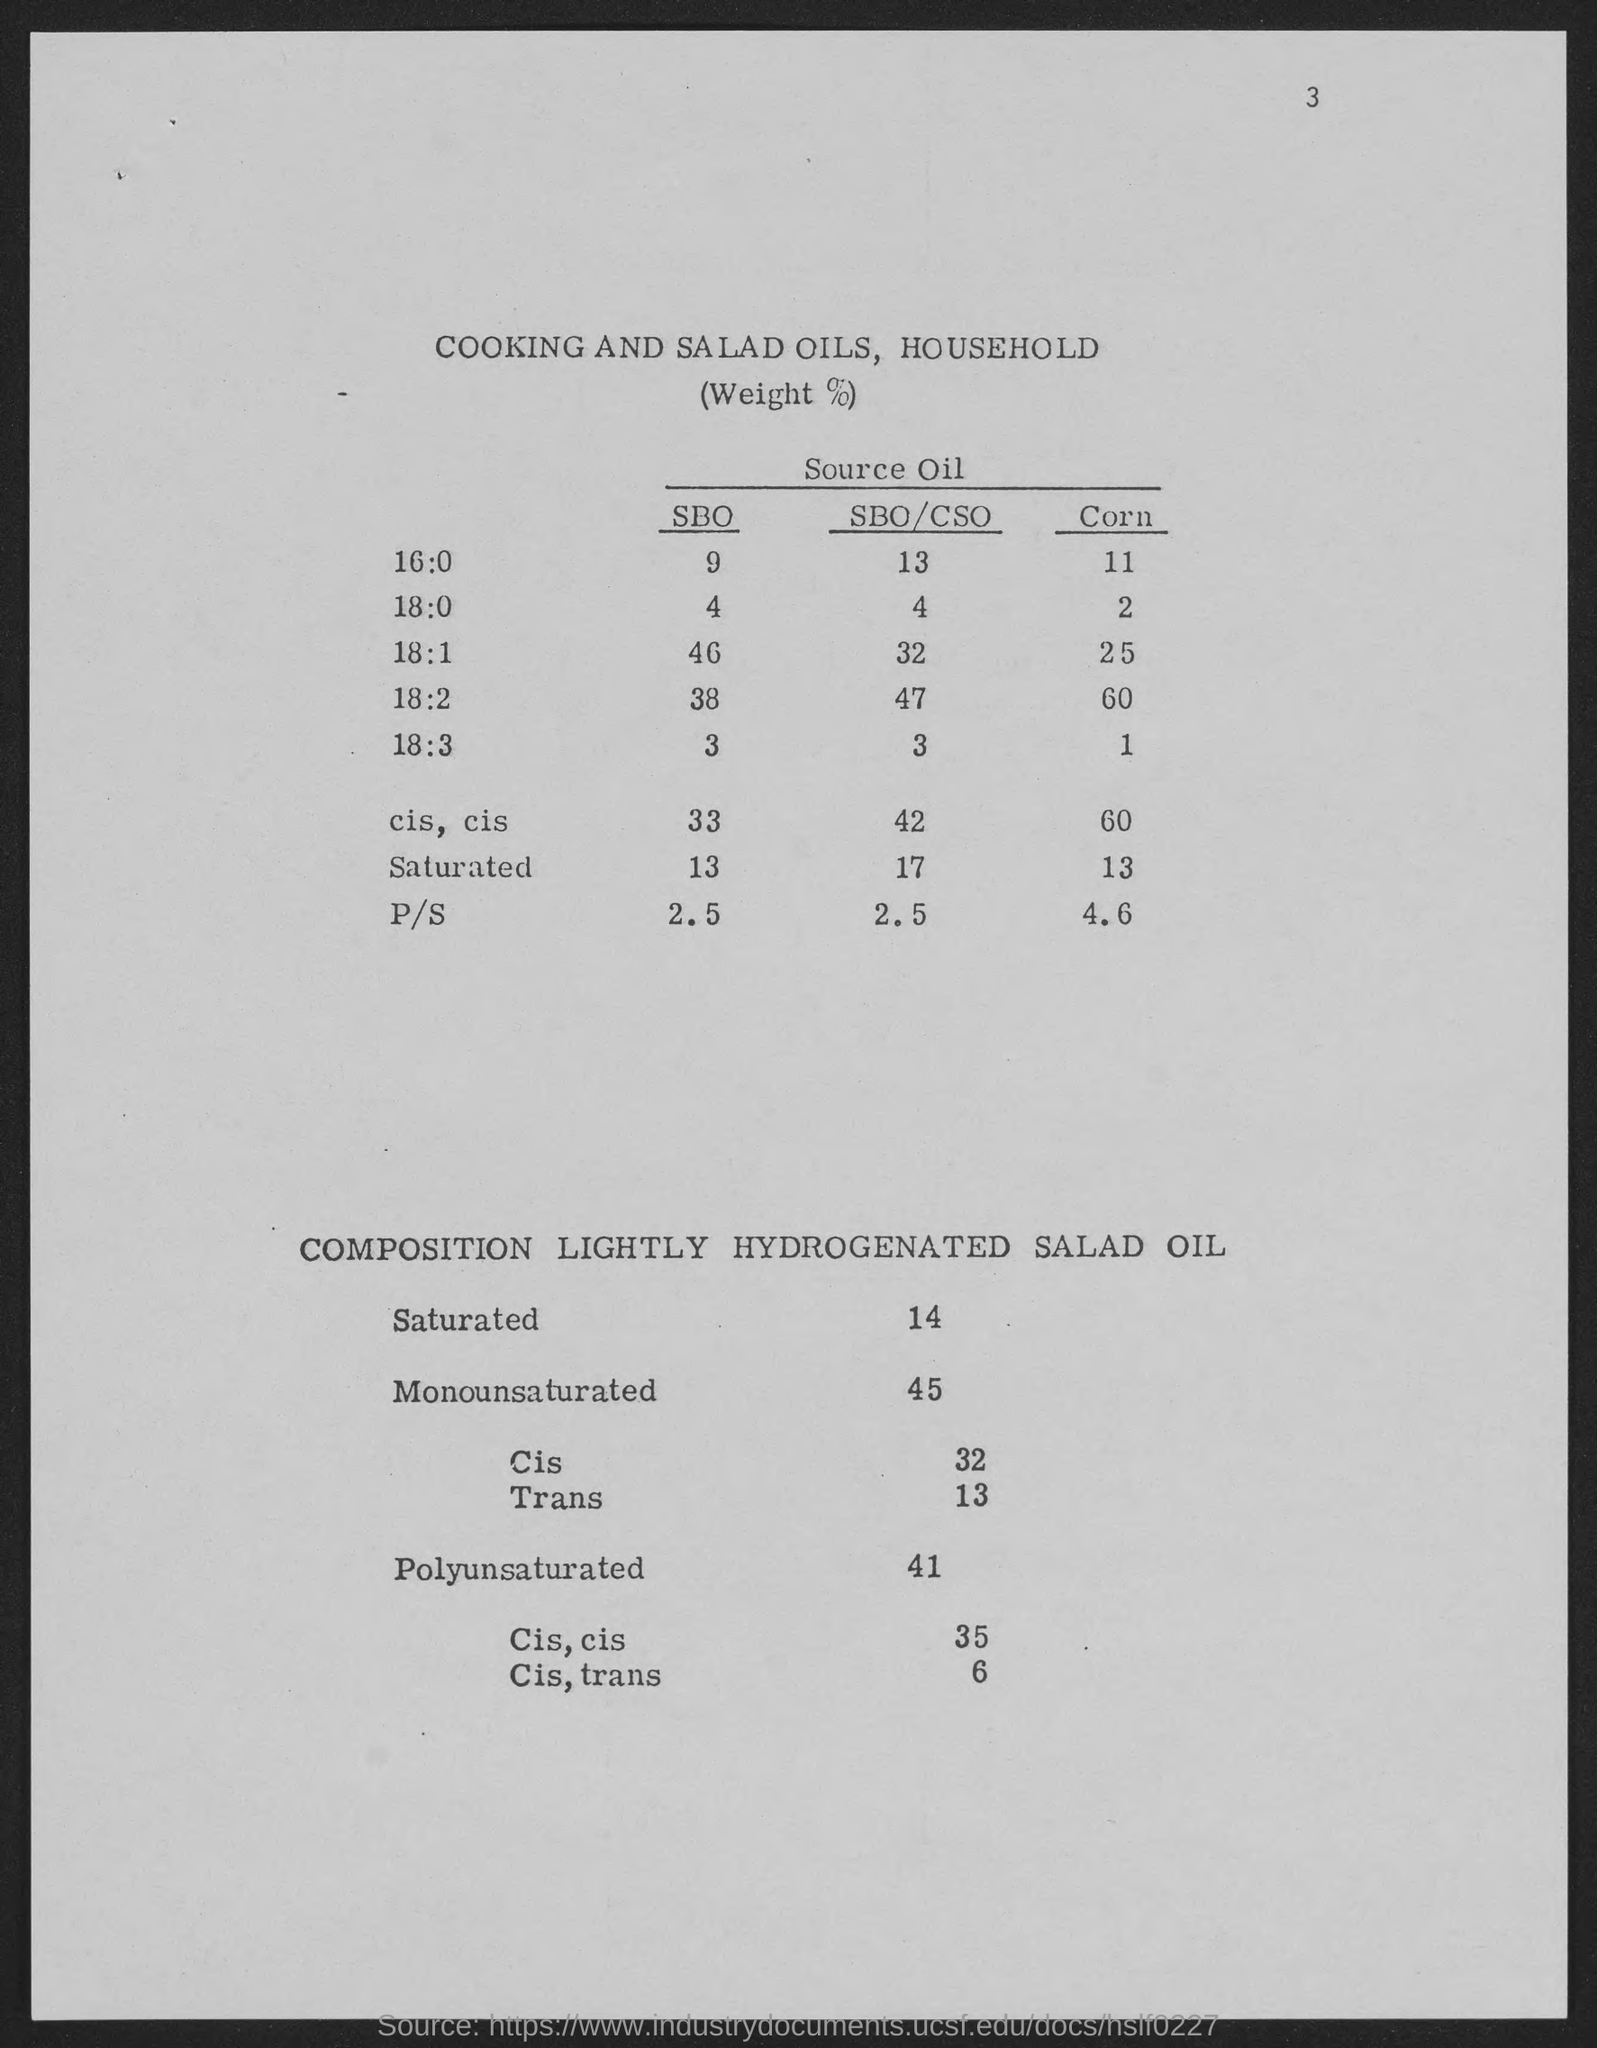What is the number at top-right corner of the page?
Offer a very short reply. 3. 